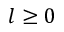<formula> <loc_0><loc_0><loc_500><loc_500>l \geq 0</formula> 